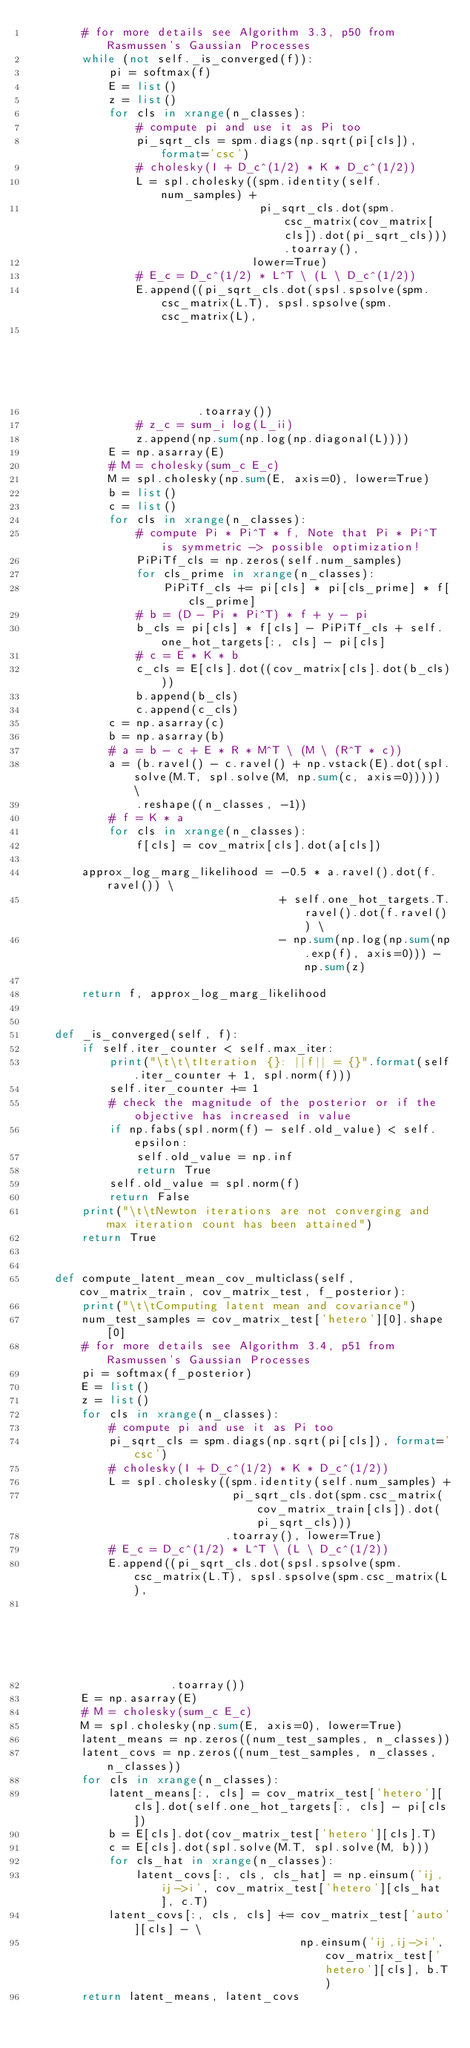<code> <loc_0><loc_0><loc_500><loc_500><_Python_>        # for more details see Algorithm 3.3, p50 from Rasmussen's Gaussian Processes
        while (not self._is_converged(f)):
            pi = softmax(f)
            E = list()
            z = list()
            for cls in xrange(n_classes):
                # compute pi and use it as Pi too
                pi_sqrt_cls = spm.diags(np.sqrt(pi[cls]), format='csc')
                # cholesky(I + D_c^(1/2) * K * D_c^(1/2))
                L = spl.cholesky((spm.identity(self.num_samples) +
                                  pi_sqrt_cls.dot(spm.csc_matrix(cov_matrix[cls]).dot(pi_sqrt_cls))).toarray(),
                                 lower=True)
                # E_c = D_c^(1/2) * L^T \ (L \ D_c^(1/2))
                E.append((pi_sqrt_cls.dot(spsl.spsolve(spm.csc_matrix(L.T), spsl.spsolve(spm.csc_matrix(L),
                                                                                         pi_sqrt_cls))))
                         .toarray())
                # z_c = sum_i log(L_ii)
                z.append(np.sum(np.log(np.diagonal(L))))
            E = np.asarray(E)
            # M = cholesky(sum_c E_c)
            M = spl.cholesky(np.sum(E, axis=0), lower=True)
            b = list()
            c = list()
            for cls in xrange(n_classes):
                # compute Pi * Pi^T * f, Note that Pi * Pi^T is symmetric -> possible optimization!
                PiPiTf_cls = np.zeros(self.num_samples)
                for cls_prime in xrange(n_classes):
                    PiPiTf_cls += pi[cls] * pi[cls_prime] * f[cls_prime]
                # b = (D - Pi * Pi^T) * f + y - pi
                b_cls = pi[cls] * f[cls] - PiPiTf_cls + self.one_hot_targets[:, cls] - pi[cls]
                # c = E * K * b
                c_cls = E[cls].dot((cov_matrix[cls].dot(b_cls)))
                b.append(b_cls)
                c.append(c_cls)
            c = np.asarray(c)
            b = np.asarray(b)
            # a = b - c + E * R * M^T \ (M \ (R^T * c))
            a = (b.ravel() - c.ravel() + np.vstack(E).dot(spl.solve(M.T, spl.solve(M, np.sum(c, axis=0))))) \
                .reshape((n_classes, -1))
            # f = K * a
            for cls in xrange(n_classes):
                f[cls] = cov_matrix[cls].dot(a[cls])

        approx_log_marg_likelihood = -0.5 * a.ravel().dot(f.ravel()) \
                                     + self.one_hot_targets.T.ravel().dot(f.ravel()) \
                                     - np.sum(np.log(np.sum(np.exp(f), axis=0))) - np.sum(z)

        return f, approx_log_marg_likelihood


    def _is_converged(self, f):
        if self.iter_counter < self.max_iter:
            print("\t\t\tIteration {}: ||f|| = {}".format(self.iter_counter + 1, spl.norm(f)))
            self.iter_counter += 1
            # check the magnitude of the posterior or if the objective has increased in value
            if np.fabs(spl.norm(f) - self.old_value) < self.epsilon:
                self.old_value = np.inf
                return True
            self.old_value = spl.norm(f)
            return False
        print("\t\tNewton iterations are not converging and max iteration count has been attained")
        return True


    def compute_latent_mean_cov_multiclass(self, cov_matrix_train, cov_matrix_test, f_posterior):
        print("\t\tComputing latent mean and covariance")
        num_test_samples = cov_matrix_test['hetero'][0].shape[0]
        # for more details see Algorithm 3.4, p51 from Rasmussen's Gaussian Processes
        pi = softmax(f_posterior)
        E = list()
        z = list()
        for cls in xrange(n_classes):
            # compute pi and use it as Pi too
            pi_sqrt_cls = spm.diags(np.sqrt(pi[cls]), format='csc')
            # cholesky(I + D_c^(1/2) * K * D_c^(1/2))
            L = spl.cholesky((spm.identity(self.num_samples) +
                              pi_sqrt_cls.dot(spm.csc_matrix(cov_matrix_train[cls]).dot(pi_sqrt_cls)))
                             .toarray(), lower=True)
            # E_c = D_c^(1/2) * L^T \ (L \ D_c^(1/2))
            E.append((pi_sqrt_cls.dot(spsl.spsolve(spm.csc_matrix(L.T), spsl.spsolve(spm.csc_matrix(L),
                                                                                     pi_sqrt_cls))))
                     .toarray())
        E = np.asarray(E)
        # M = cholesky(sum_c E_c)
        M = spl.cholesky(np.sum(E, axis=0), lower=True)
        latent_means = np.zeros((num_test_samples, n_classes))
        latent_covs = np.zeros((num_test_samples, n_classes, n_classes))
        for cls in xrange(n_classes):
            latent_means[:, cls] = cov_matrix_test['hetero'][cls].dot(self.one_hot_targets[:, cls] - pi[cls])
            b = E[cls].dot(cov_matrix_test['hetero'][cls].T)
            c = E[cls].dot(spl.solve(M.T, spl.solve(M, b)))
            for cls_hat in xrange(n_classes):
                latent_covs[:, cls, cls_hat] = np.einsum('ij,ij->i', cov_matrix_test['hetero'][cls_hat], c.T)
            latent_covs[:, cls, cls] += cov_matrix_test['auto'][cls] - \
                                        np.einsum('ij,ij->i', cov_matrix_test['hetero'][cls], b.T)
        return latent_means, latent_covs
</code> 